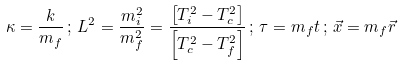Convert formula to latex. <formula><loc_0><loc_0><loc_500><loc_500>\kappa = \frac { k } { m _ { f } } \, ; \, L ^ { 2 } = \frac { m _ { i } ^ { 2 } } { m _ { f } ^ { 2 } } = \frac { \left [ T ^ { 2 } _ { i } - T ^ { 2 } _ { c } \right ] } { \left [ T ^ { 2 } _ { c } - T ^ { 2 } _ { f } \right ] } \, ; \, \tau = m _ { f } t \, ; \, \vec { x } = m _ { f } \vec { r }</formula> 